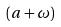<formula> <loc_0><loc_0><loc_500><loc_500>( a + \omega )</formula> 